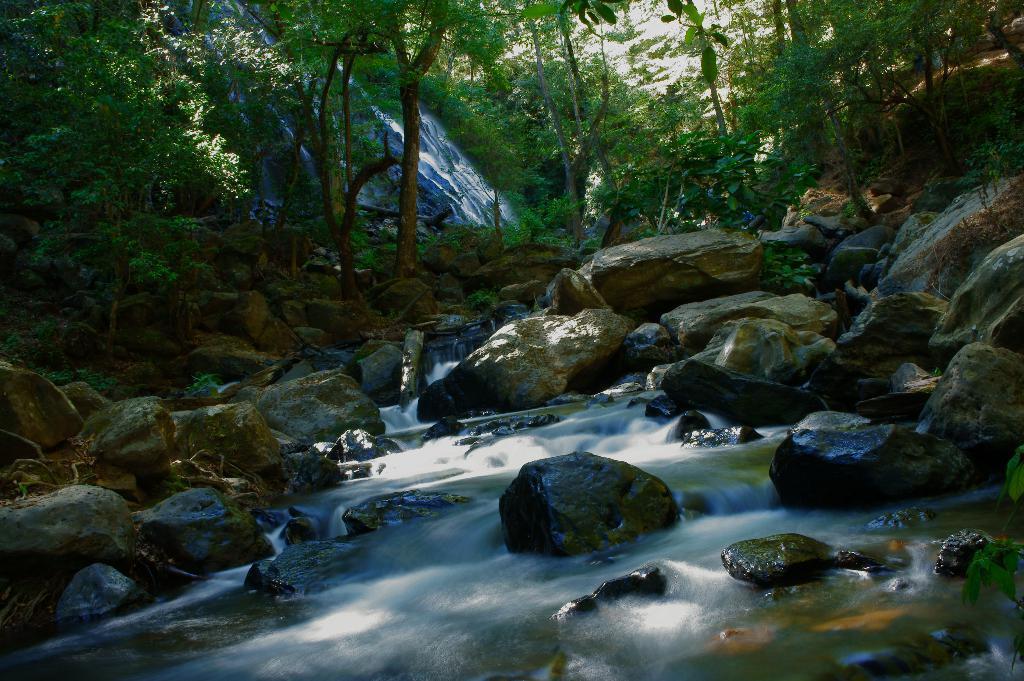Describe this image in one or two sentences. This picture is clicked outside. In the foreground we can see a water body and the rocks. In the background there is a waterfall and we can see the plants and some trees. 